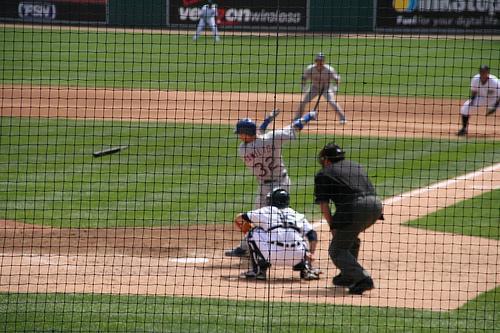How many players have a piece of a bat in their hands?
Give a very brief answer. 1. 